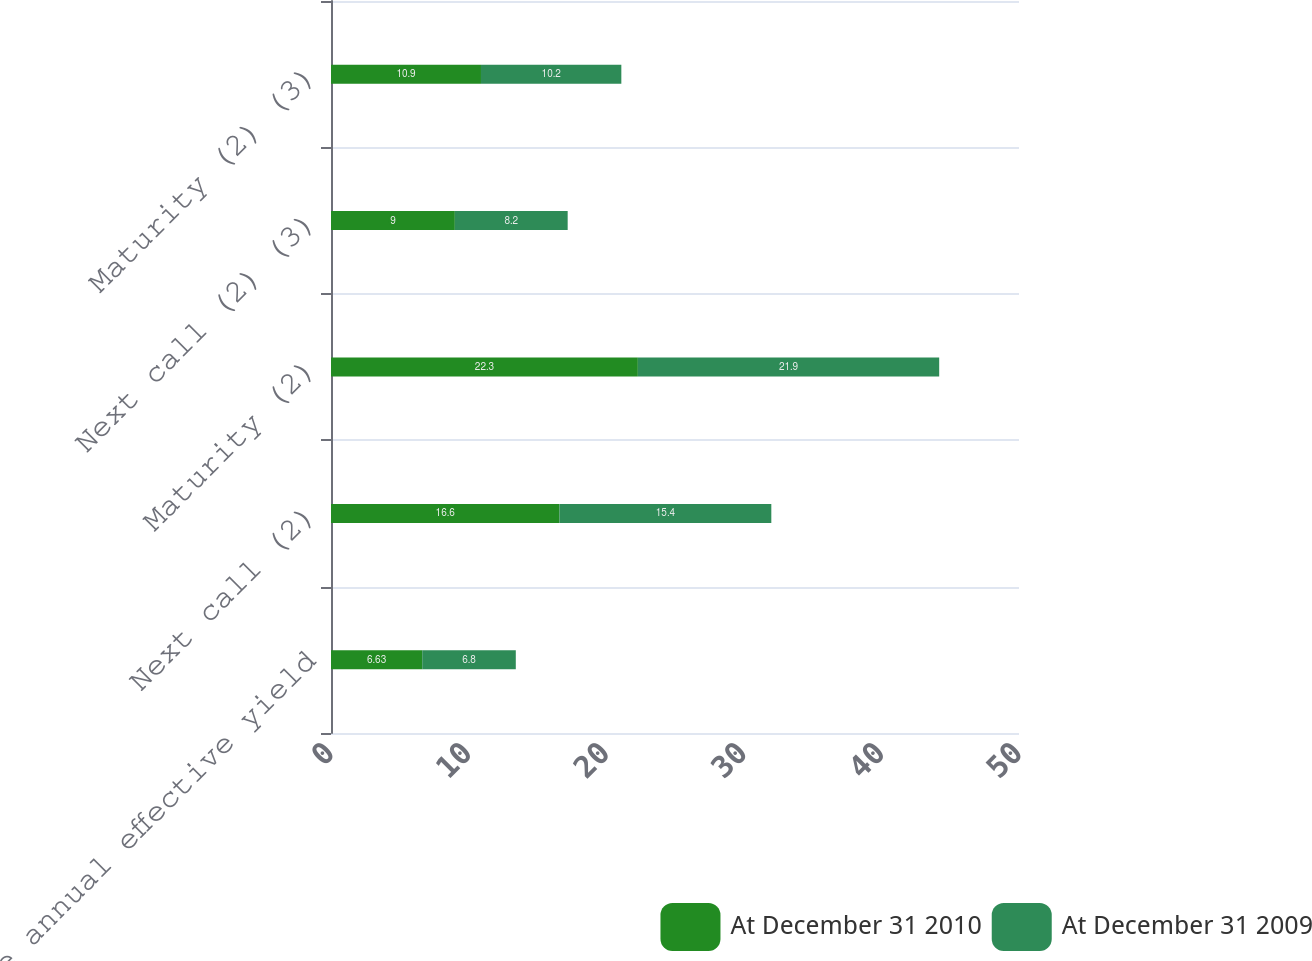Convert chart to OTSL. <chart><loc_0><loc_0><loc_500><loc_500><stacked_bar_chart><ecel><fcel>Average annual effective yield<fcel>Next call (2)<fcel>Maturity (2)<fcel>Next call (2) (3)<fcel>Maturity (2) (3)<nl><fcel>At December 31 2010<fcel>6.63<fcel>16.6<fcel>22.3<fcel>9<fcel>10.9<nl><fcel>At December 31 2009<fcel>6.8<fcel>15.4<fcel>21.9<fcel>8.2<fcel>10.2<nl></chart> 